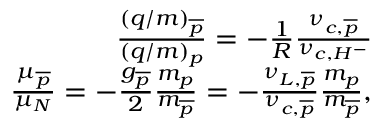Convert formula to latex. <formula><loc_0><loc_0><loc_500><loc_500>\begin{array} { r } { \frac { ( q / m ) _ { \overline { p } } } { ( q / m ) _ { p } } = - \frac { 1 } { R } \frac { \nu _ { c , \overline { p } } } { \nu _ { c , H ^ { - } } } } \\ { \frac { \mu _ { \overline { p } } } { \mu _ { N } } = - \frac { g _ { \overline { p } } } { 2 } \frac { m _ { p } } { m _ { \overline { p } } } = - \frac { \nu _ { L , \overline { p } } } { \nu _ { c , \overline { p } } } \frac { m _ { p } } { m _ { \overline { p } } } , } \end{array}</formula> 